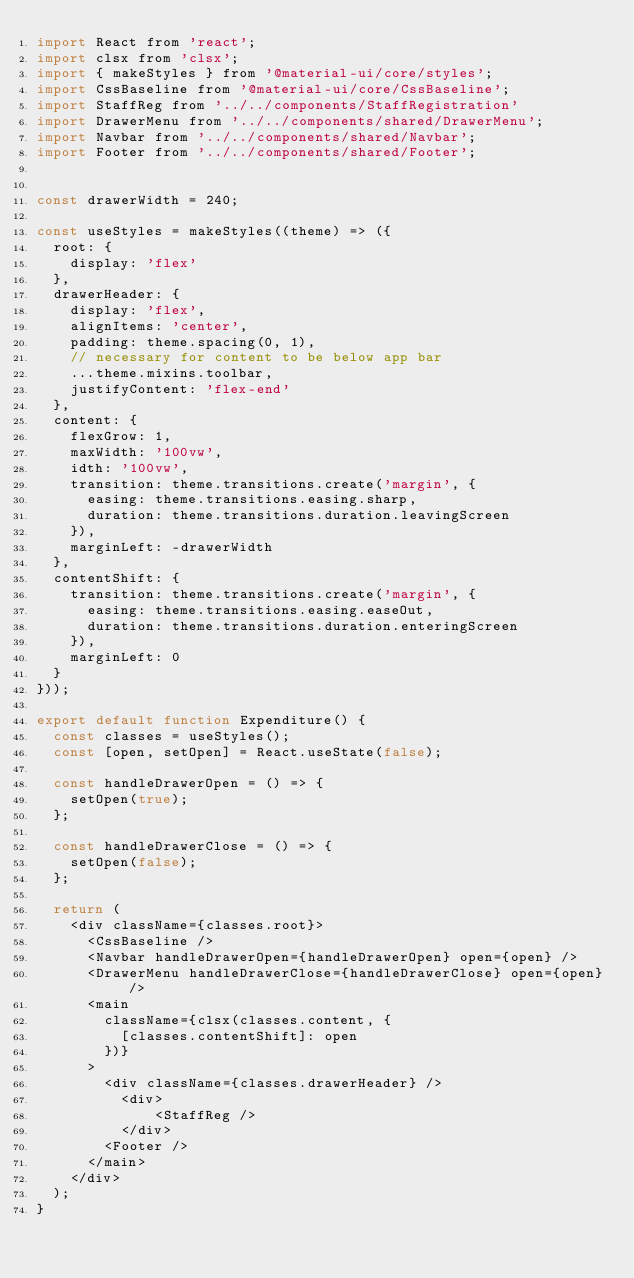Convert code to text. <code><loc_0><loc_0><loc_500><loc_500><_JavaScript_>import React from 'react';
import clsx from 'clsx';
import { makeStyles } from '@material-ui/core/styles';
import CssBaseline from '@material-ui/core/CssBaseline';
import StaffReg from '../../components/StaffRegistration'
import DrawerMenu from '../../components/shared/DrawerMenu';
import Navbar from '../../components/shared/Navbar';
import Footer from '../../components/shared/Footer';


const drawerWidth = 240;

const useStyles = makeStyles((theme) => ({
  root: {
    display: 'flex'
  },
  drawerHeader: {
    display: 'flex',
    alignItems: 'center',
    padding: theme.spacing(0, 1),
    // necessary for content to be below app bar
    ...theme.mixins.toolbar,
    justifyContent: 'flex-end'
  },
  content: {
    flexGrow: 1,
    maxWidth: '100vw',
    idth: '100vw',
    transition: theme.transitions.create('margin', {
      easing: theme.transitions.easing.sharp,
      duration: theme.transitions.duration.leavingScreen
    }),
    marginLeft: -drawerWidth
  },
  contentShift: {
    transition: theme.transitions.create('margin', {
      easing: theme.transitions.easing.easeOut,
      duration: theme.transitions.duration.enteringScreen
    }),
    marginLeft: 0
  }
}));

export default function Expenditure() {
  const classes = useStyles();
  const [open, setOpen] = React.useState(false);

  const handleDrawerOpen = () => {
    setOpen(true);
  };

  const handleDrawerClose = () => {
    setOpen(false);
  };

  return (
    <div className={classes.root}>
      <CssBaseline />
      <Navbar handleDrawerOpen={handleDrawerOpen} open={open} />
      <DrawerMenu handleDrawerClose={handleDrawerClose} open={open} />
      <main
        className={clsx(classes.content, {
          [classes.contentShift]: open
        })}
      >
        <div className={classes.drawerHeader} />
          <div>
              <StaffReg />
          </div>
        <Footer />
      </main>
    </div>
  );
}
</code> 